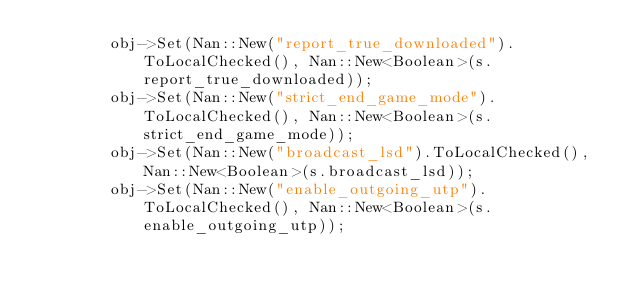<code> <loc_0><loc_0><loc_500><loc_500><_C++_>        obj->Set(Nan::New("report_true_downloaded").ToLocalChecked(), Nan::New<Boolean>(s.report_true_downloaded));
        obj->Set(Nan::New("strict_end_game_mode").ToLocalChecked(), Nan::New<Boolean>(s.strict_end_game_mode));
        obj->Set(Nan::New("broadcast_lsd").ToLocalChecked(), Nan::New<Boolean>(s.broadcast_lsd));
        obj->Set(Nan::New("enable_outgoing_utp").ToLocalChecked(), Nan::New<Boolean>(s.enable_outgoing_utp));</code> 